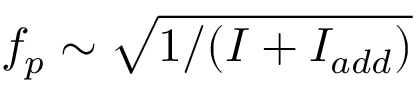<formula> <loc_0><loc_0><loc_500><loc_500>f _ { p } \sim \sqrt { 1 / ( I + I _ { a d d } ) }</formula> 